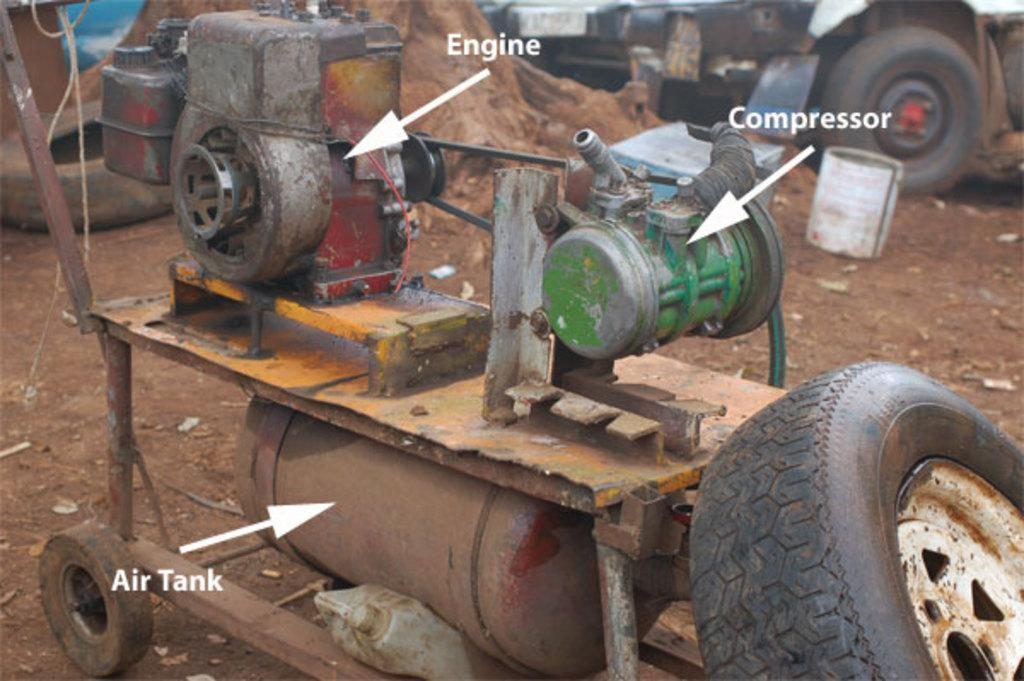What is the main object in the image? There is an engine in the image. Where are the wheels located in the image? There is a wheel in the top left and another in the bottom right of the image. What can be seen in the top right of the image? There is a vehicle and a drum in the top right of the image. How many eggs are visible in the image? There are no eggs present in the image. What type of bottle can be seen in the image? There is no bottle present in the image. 